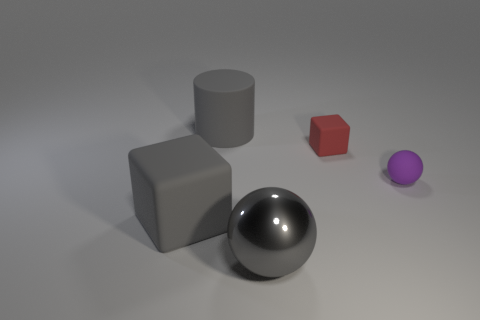Is the number of large purple rubber cylinders greater than the number of things?
Keep it short and to the point. No. How many other objects are there of the same color as the metal sphere?
Your answer should be compact. 2. What number of things are big matte cubes or small rubber objects?
Offer a terse response. 3. Do the big gray matte thing in front of the tiny purple matte ball and the red matte thing have the same shape?
Offer a terse response. Yes. There is a big thing behind the tiny rubber thing that is left of the small matte ball; what is its color?
Your response must be concise. Gray. Are there fewer rubber cylinders than tiny objects?
Provide a short and direct response. Yes. Is there a red thing that has the same material as the gray cylinder?
Make the answer very short. Yes. Does the shiny object have the same shape as the gray rubber object behind the tiny rubber block?
Keep it short and to the point. No. Are there any large gray cylinders to the right of the large metallic thing?
Provide a succinct answer. No. What number of large shiny things are the same shape as the small purple matte object?
Your answer should be very brief. 1. 